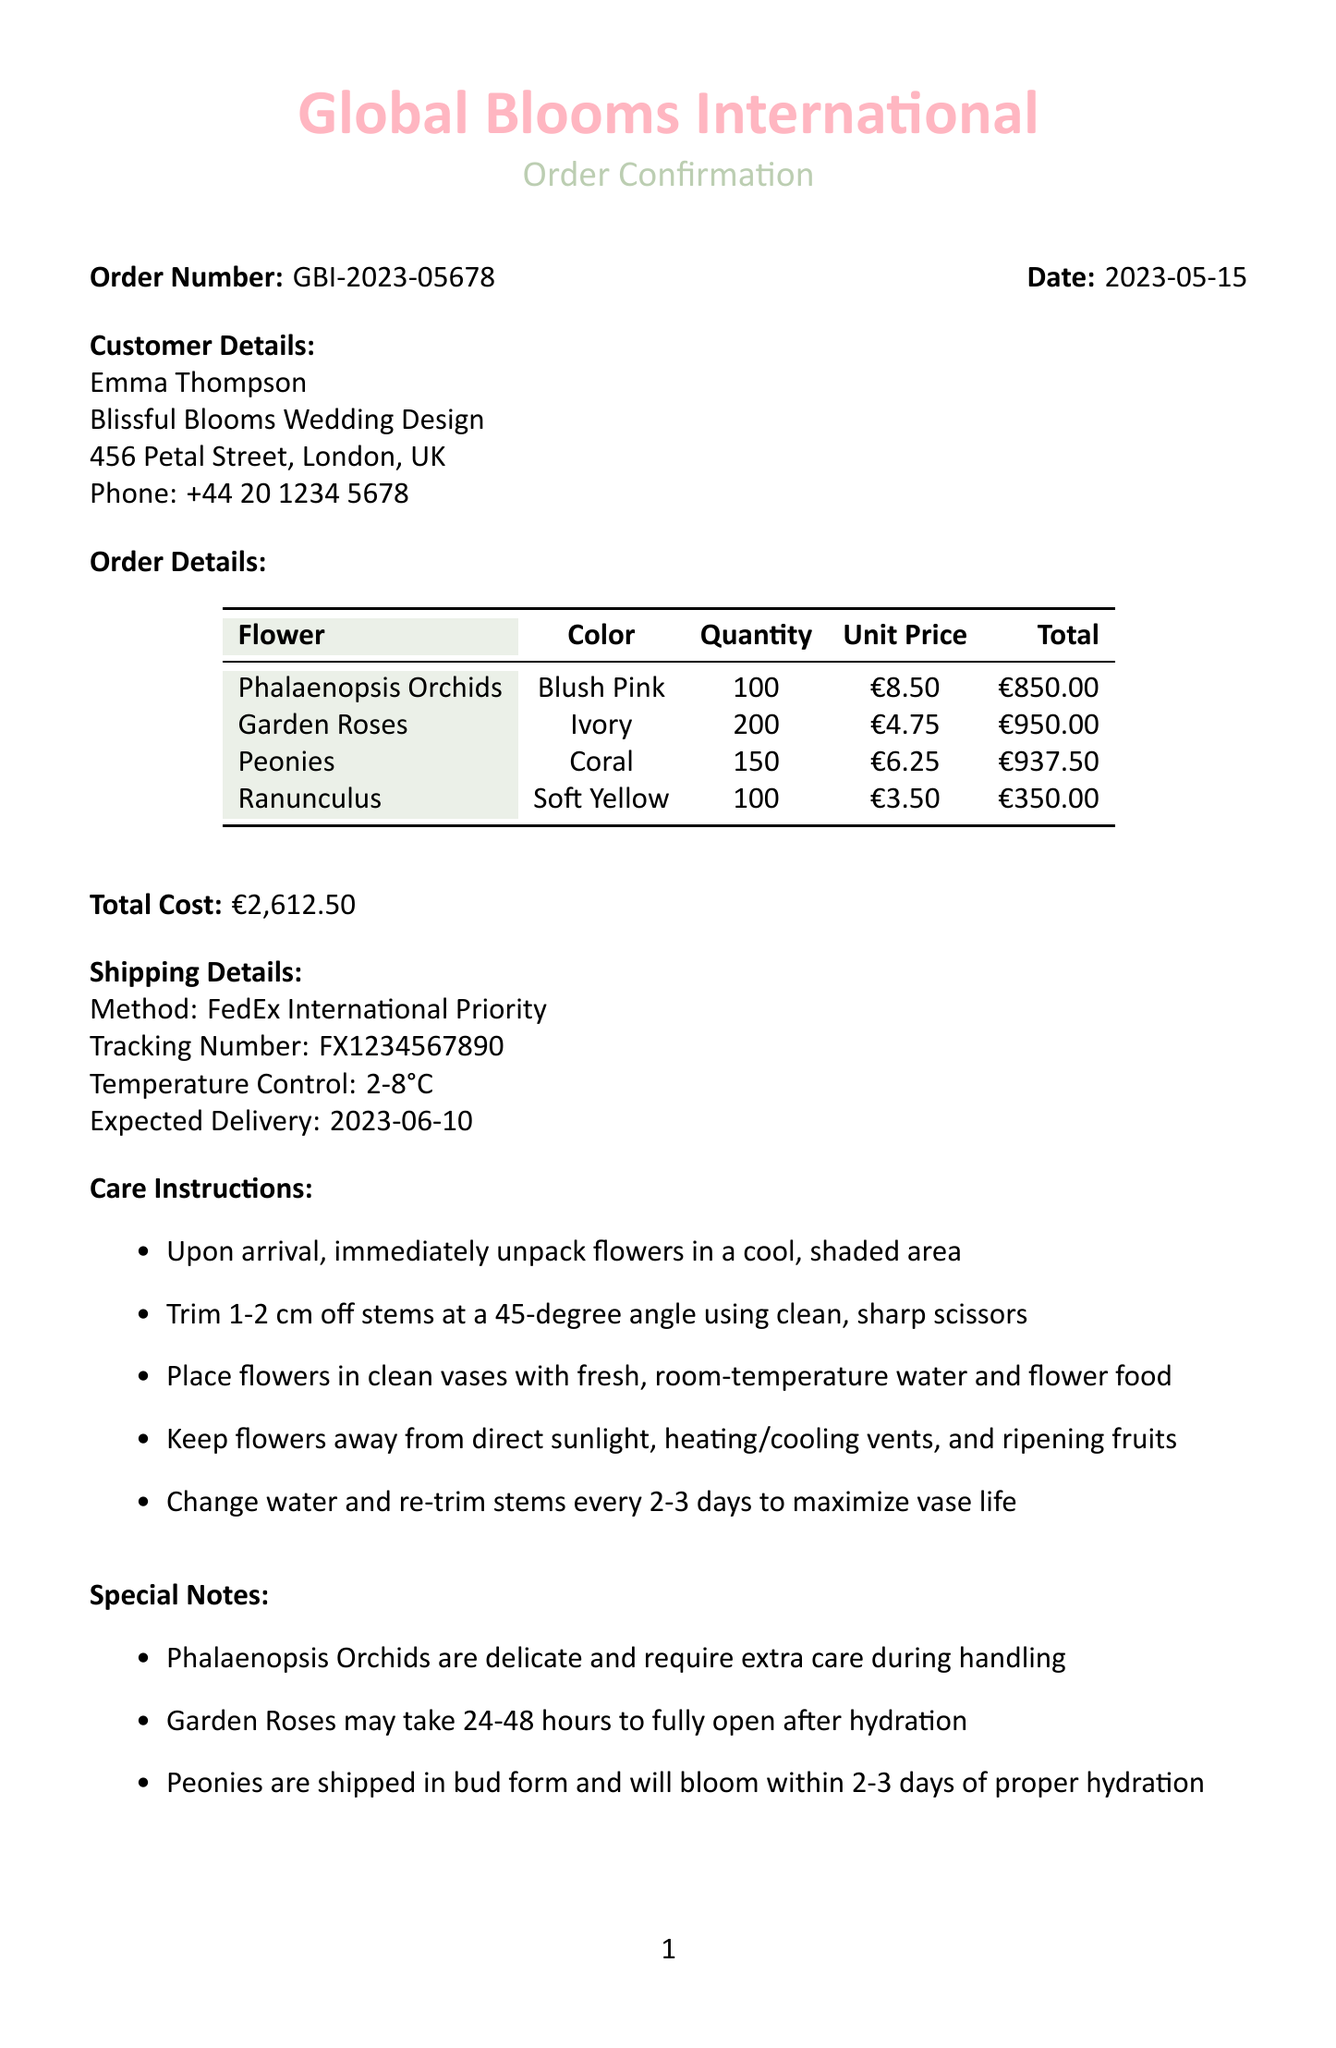What is the order number? The order number is stated clearly in the document under Order Details.
Answer: GBI-2023-05678 What is the expected delivery date? The expected delivery date is listed in the Shipping Details section of the document.
Answer: 2023-06-10 How many Garden Roses were ordered? The quantity of Garden Roses is specified in the Order Details section.
Answer: 200 What temperature control is required during shipping? The document provides specific shipping details regarding temperature control.
Answer: 2-8°C Who should be contacted for questions regarding the order? The contact information for inquiries is provided at the end of the document.
Answer: Global Blooms International Why may Garden Roses take longer to show full bloom? The special notes section explains why Garden Roses may take longer.
Answer: 24-48 hours after hydration What is the total cost of the order? The total cost is summarized at the end of the Order Details section.
Answer: €2,612.50 What care is recommended for Phalaenopsis Orchids? The care instructions mention handling for Phalaenopsis Orchids in special notes.
Answer: Extra care during handling 